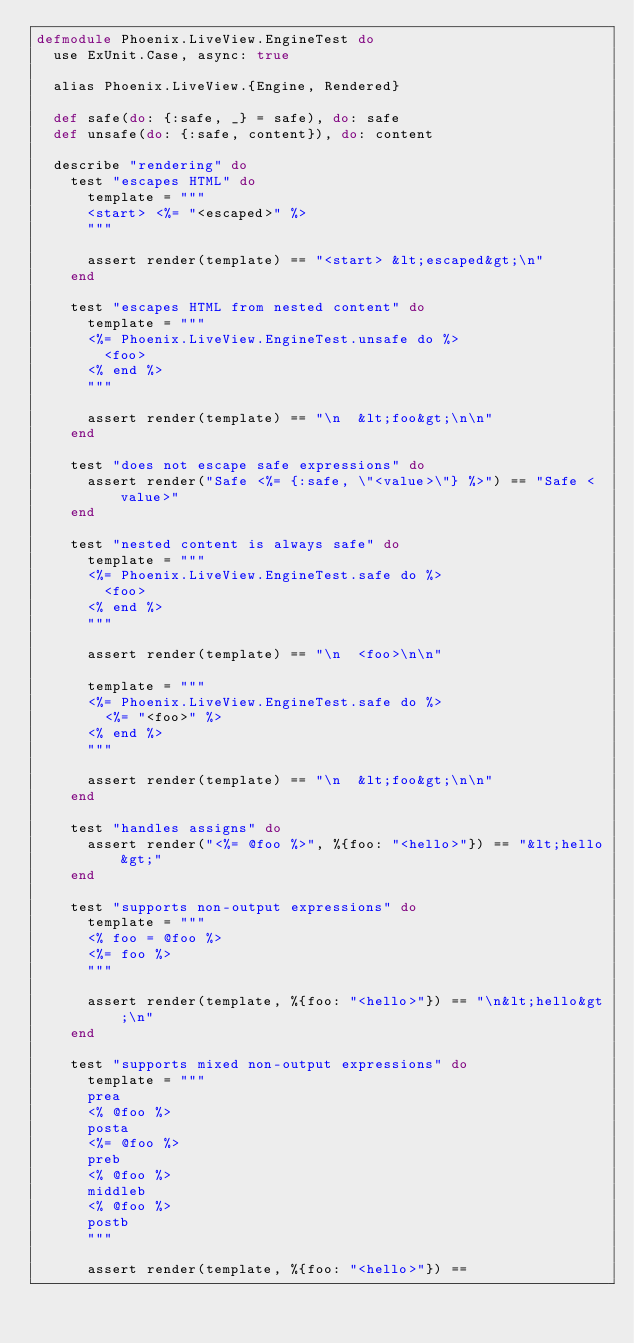<code> <loc_0><loc_0><loc_500><loc_500><_Elixir_>defmodule Phoenix.LiveView.EngineTest do
  use ExUnit.Case, async: true

  alias Phoenix.LiveView.{Engine, Rendered}

  def safe(do: {:safe, _} = safe), do: safe
  def unsafe(do: {:safe, content}), do: content

  describe "rendering" do
    test "escapes HTML" do
      template = """
      <start> <%= "<escaped>" %>
      """

      assert render(template) == "<start> &lt;escaped&gt;\n"
    end

    test "escapes HTML from nested content" do
      template = """
      <%= Phoenix.LiveView.EngineTest.unsafe do %>
        <foo>
      <% end %>
      """

      assert render(template) == "\n  &lt;foo&gt;\n\n"
    end

    test "does not escape safe expressions" do
      assert render("Safe <%= {:safe, \"<value>\"} %>") == "Safe <value>"
    end

    test "nested content is always safe" do
      template = """
      <%= Phoenix.LiveView.EngineTest.safe do %>
        <foo>
      <% end %>
      """

      assert render(template) == "\n  <foo>\n\n"

      template = """
      <%= Phoenix.LiveView.EngineTest.safe do %>
        <%= "<foo>" %>
      <% end %>
      """

      assert render(template) == "\n  &lt;foo&gt;\n\n"
    end

    test "handles assigns" do
      assert render("<%= @foo %>", %{foo: "<hello>"}) == "&lt;hello&gt;"
    end

    test "supports non-output expressions" do
      template = """
      <% foo = @foo %>
      <%= foo %>
      """

      assert render(template, %{foo: "<hello>"}) == "\n&lt;hello&gt;\n"
    end

    test "supports mixed non-output expressions" do
      template = """
      prea
      <% @foo %>
      posta
      <%= @foo %>
      preb
      <% @foo %>
      middleb
      <% @foo %>
      postb
      """

      assert render(template, %{foo: "<hello>"}) ==</code> 